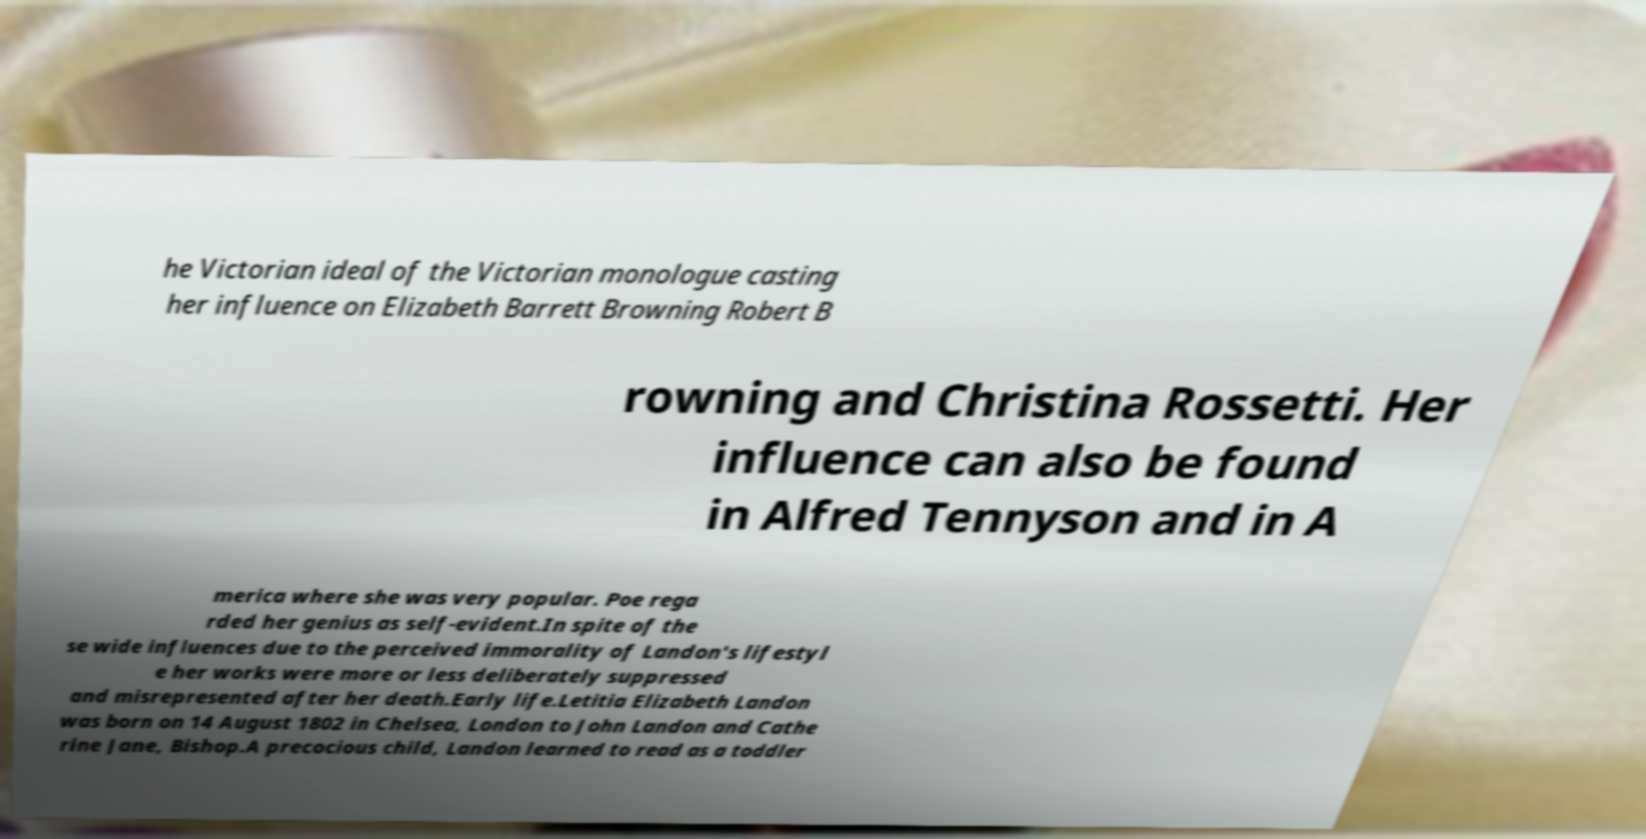Can you accurately transcribe the text from the provided image for me? he Victorian ideal of the Victorian monologue casting her influence on Elizabeth Barrett Browning Robert B rowning and Christina Rossetti. Her influence can also be found in Alfred Tennyson and in A merica where she was very popular. Poe rega rded her genius as self-evident.In spite of the se wide influences due to the perceived immorality of Landon's lifestyl e her works were more or less deliberately suppressed and misrepresented after her death.Early life.Letitia Elizabeth Landon was born on 14 August 1802 in Chelsea, London to John Landon and Cathe rine Jane, Bishop.A precocious child, Landon learned to read as a toddler 